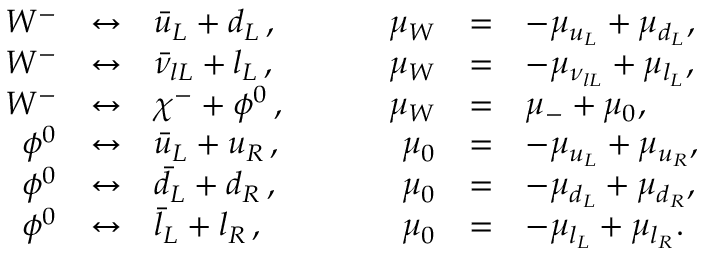<formula> <loc_0><loc_0><loc_500><loc_500>\begin{array} { r c l c r c l } { { W ^ { - } } } & { \leftrightarrow } & { { \bar { u } _ { L } + d _ { L } \, , } } & { { \mu _ { W } } } & { = } & { { - \mu _ { u _ { L } } + \mu _ { d _ { L } } , } } \\ { { W ^ { - } } } & { \leftrightarrow } & { { \bar { \nu } _ { l L } + l _ { L } \, , } } & { { \mu _ { W } } } & { = } & { { - \mu _ { \nu _ { l L } } + \mu _ { l _ { L } } , } } \\ { { W ^ { - } } } & { \leftrightarrow } & { { \chi ^ { - } + \phi ^ { 0 } \, , } } & { { \mu _ { W } } } & { = } & { { \mu _ { - } + \mu _ { 0 } , } } \\ { { \phi ^ { 0 } } } & { \leftrightarrow } & { { \bar { u } _ { L } + u _ { R } \, , } } & { { \mu _ { 0 } } } & { = } & { { - \mu _ { u _ { L } } + \mu _ { u _ { R } } , } } \\ { { \phi ^ { 0 } } } & { \leftrightarrow } & { { \bar { d } _ { L } + d _ { R } \, , } } & { { \mu _ { 0 } } } & { = } & { { - \mu _ { d _ { L } } + \mu _ { d _ { R } } , } } \\ { { \phi ^ { 0 } } } & { \leftrightarrow } & { { \bar { l } _ { L } + l _ { R } \, , } } & { { \mu _ { 0 } } } & { = } & { { - \mu _ { l _ { L } } + \mu _ { l _ { R } } . } } \end{array}</formula> 